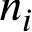Convert formula to latex. <formula><loc_0><loc_0><loc_500><loc_500>n _ { i }</formula> 